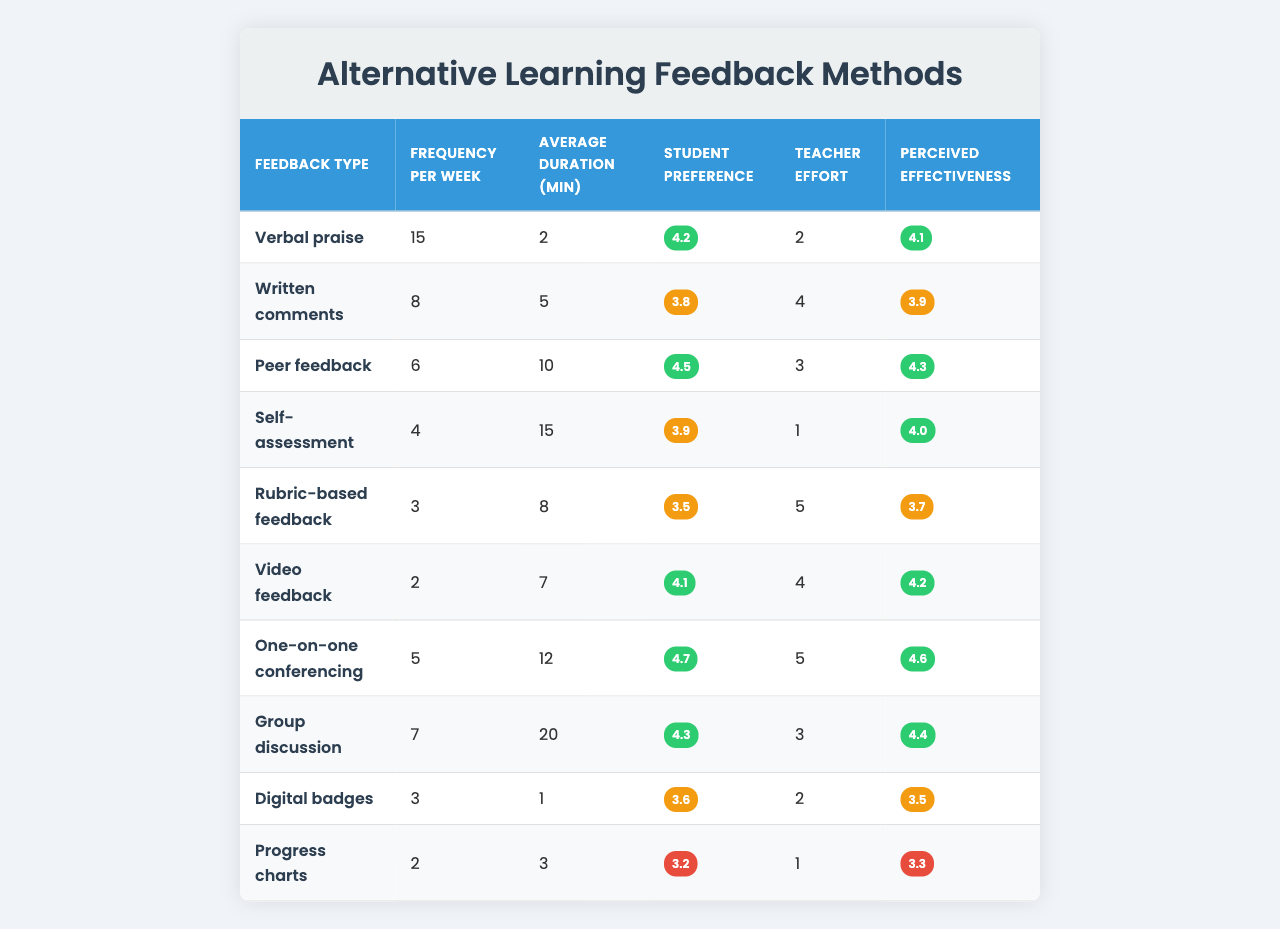What is the most frequently used type of feedback? By examining the "Frequency per Week" column, "Verbal praise" has the highest value of 15, indicating it is the most frequently used feedback type.
Answer: Verbal praise How many types of feedback have a frequency of 5 or more? Looking at the "Frequency per Week" column, there are 5 types of feedback that have values of 5 or more: "Verbal praise" (15), "Written comments" (8), "One-on-one conferencing" (5), "Group discussion" (7), and "Peer feedback" (6).
Answer: 5 Which feedback type has the lowest average duration? The "Average Duration (min)" column shows that "Progress charts" has the lowest value of 1 minute.
Answer: Progress charts What is the average student preference rating across all feedback types? To find the average, sum all the student preference ratings (4.2 + 3.8 + 4.5 + 3.9 + 3.5 + 4.1 + 4.7 + 4.3 + 3.6 + 3.2 = 43.8), then divide by the number of feedback types (10), which equals 4.38.
Answer: 4.38 Is "Self-assessment" rated higher by students than "Rubric-based feedback"? Comparing the "Student Preference" ratings, "Self-assessment" is rated at 3.9 and "Rubric-based feedback" at 3.5. Since 3.9 is greater than 3.5, the statement is true.
Answer: Yes Which type of feedback has the highest perceived effectiveness and what is that value? Looking at the "Perceived Effectiveness" column, "One-on-one conferencing" has the highest rating at 4.6.
Answer: One-on-one conferencing, 4.6 What is the total effort level reported for all types of feedback? To find the total teacher effort, sum all values in the "Teacher Effort" column (2 + 4 + 3 + 1 + 5 + 4 + 5 + 3 + 2 + 1 = 30).
Answer: 30 How does the average duration of feedback compare to its frequency? To draw comparisons, we analyze "Verbal praise" with a high frequency (15) and low average duration (2 minutes) against "Group discussion" which has a medium frequency (7) and a high duration (20 minutes). It suggests that higher frequency feedback types may not necessarily lead to longer durations.
Answer: Varies by type Which feedback type do students prefer the most? The "Student Preference" ratings reveal that "One-on-one conferencing" has the highest score of 4.7, indicating it is the most preferred feedback type among students.
Answer: One-on-one conferencing Are "Video feedback" and "Digital badges" perceived equally in terms of effectiveness? Comparing the "Perceived Effectiveness" ratings, "Video feedback" is rated 4.2 and "Digital badges" is rated 3.5. Since these values are not equal, they are perceived differently.
Answer: No 